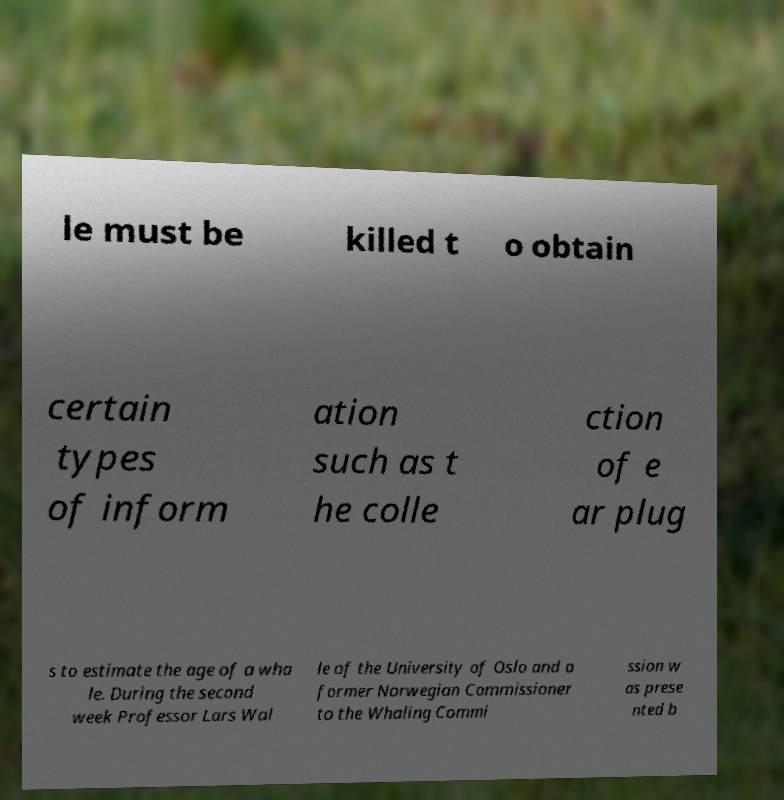Please read and relay the text visible in this image. What does it say? le must be killed t o obtain certain types of inform ation such as t he colle ction of e ar plug s to estimate the age of a wha le. During the second week Professor Lars Wal le of the University of Oslo and a former Norwegian Commissioner to the Whaling Commi ssion w as prese nted b 